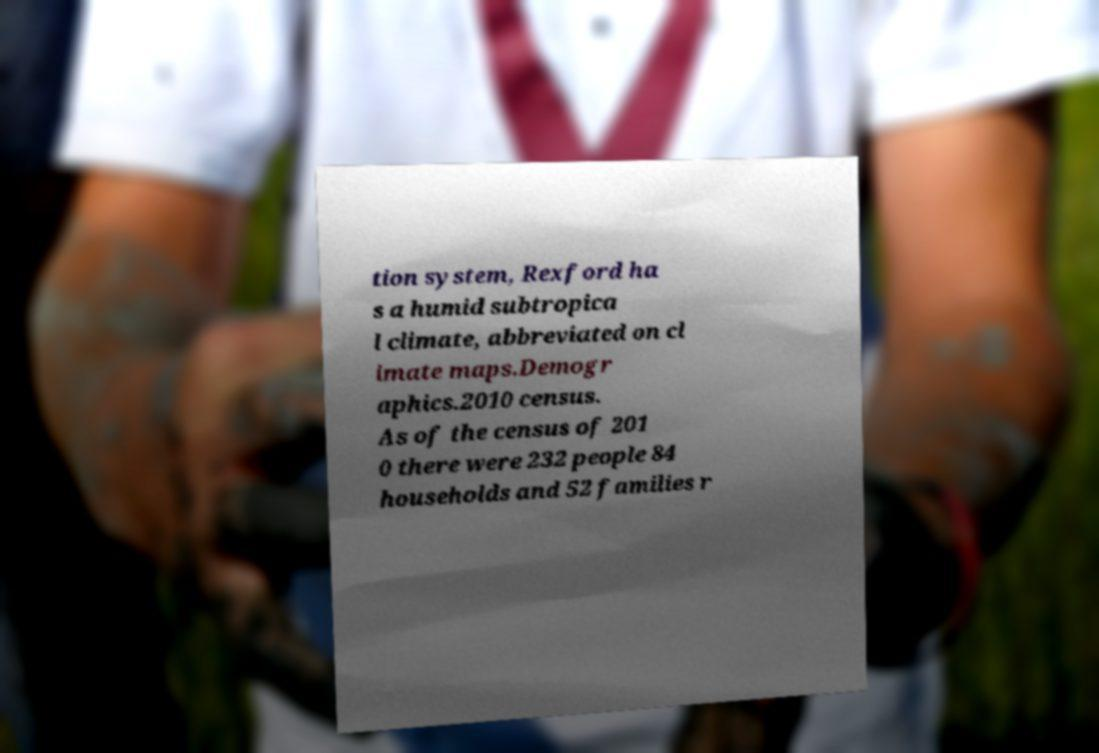Could you extract and type out the text from this image? tion system, Rexford ha s a humid subtropica l climate, abbreviated on cl imate maps.Demogr aphics.2010 census. As of the census of 201 0 there were 232 people 84 households and 52 families r 